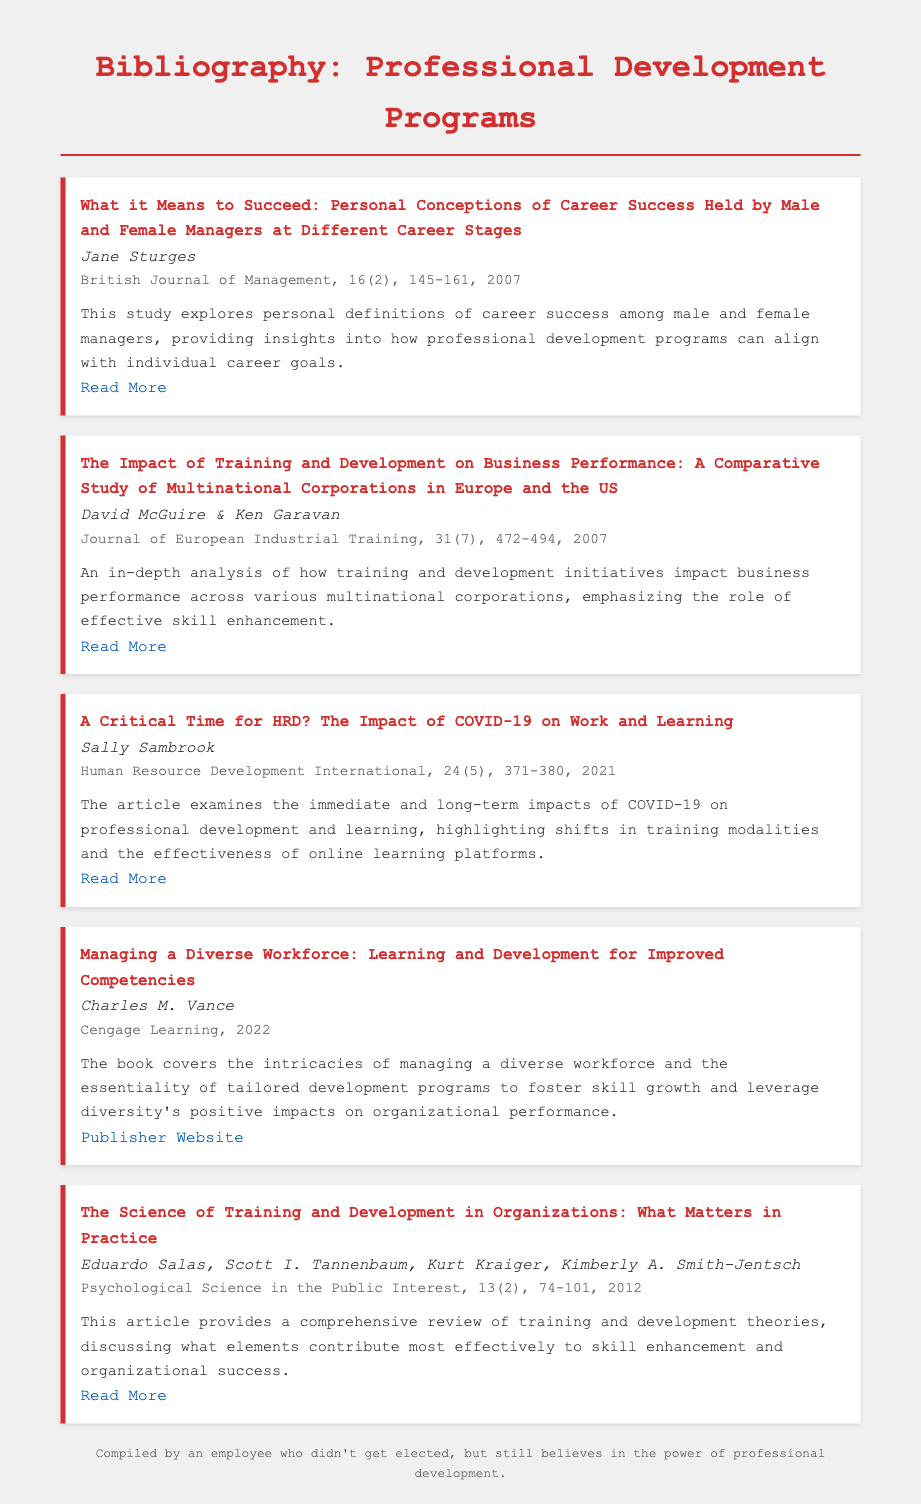what is the title of the first entry? The title of the first entry is the main heading provided for that citation in the bibliography.
Answer: What it Means to Succeed: Personal Conceptions of Career Success Held by Male and Female Managers at Different Career Stages who authored the fourth entry? The author of the fourth entry is listed directly beneath the title.
Answer: Charles M. Vance what year was the article by Sally Sambrook published? The publication year is typically mentioned in the citation details of each entry.
Answer: 2021 how many pages does the article by David McGuire & Ken Garavan cover? The page range is specified in the citation details of that entry.
Answer: 472-494 what is the focus of the book by Charles M. Vance? The summary of the entry gives insight into the core subject being addressed in the publication.
Answer: Managing a diverse workforce how does the study by Eduardo Salas et al. contribute to skill enhancement? This requires understanding of the summary that highlights the main contributions of the study.
Answer: Discussing what elements contribute most effectively to skill enhancement what common theme is presented in the entries regarding professional development? By analyzing the summaries, we can deduce the overarching themes discussed in the bibliography.
Answer: The effectiveness of training and development how many entries are listed in the bibliography? The total number of entries can be counted from the visible sections of the document.
Answer: Five 